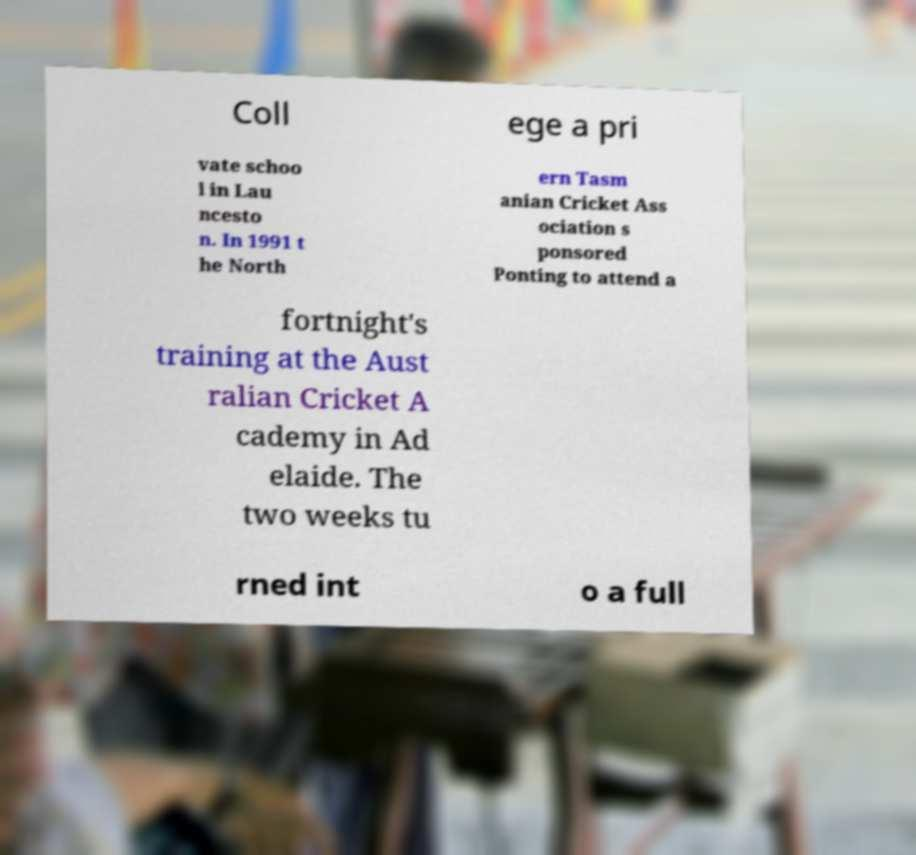For documentation purposes, I need the text within this image transcribed. Could you provide that? Coll ege a pri vate schoo l in Lau ncesto n. In 1991 t he North ern Tasm anian Cricket Ass ociation s ponsored Ponting to attend a fortnight's training at the Aust ralian Cricket A cademy in Ad elaide. The two weeks tu rned int o a full 